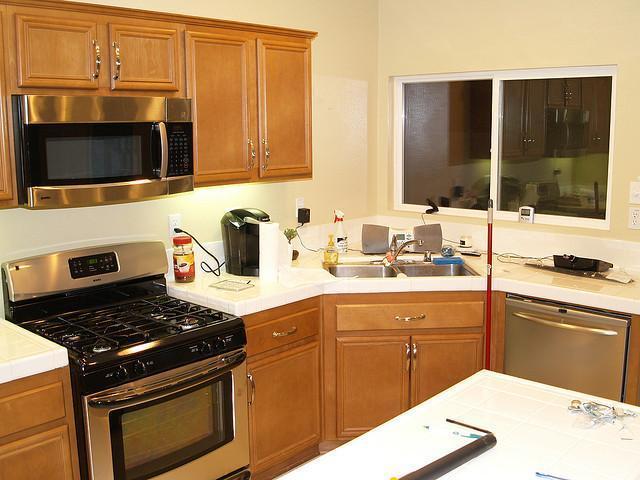How many microwaves can be seen?
Give a very brief answer. 1. 